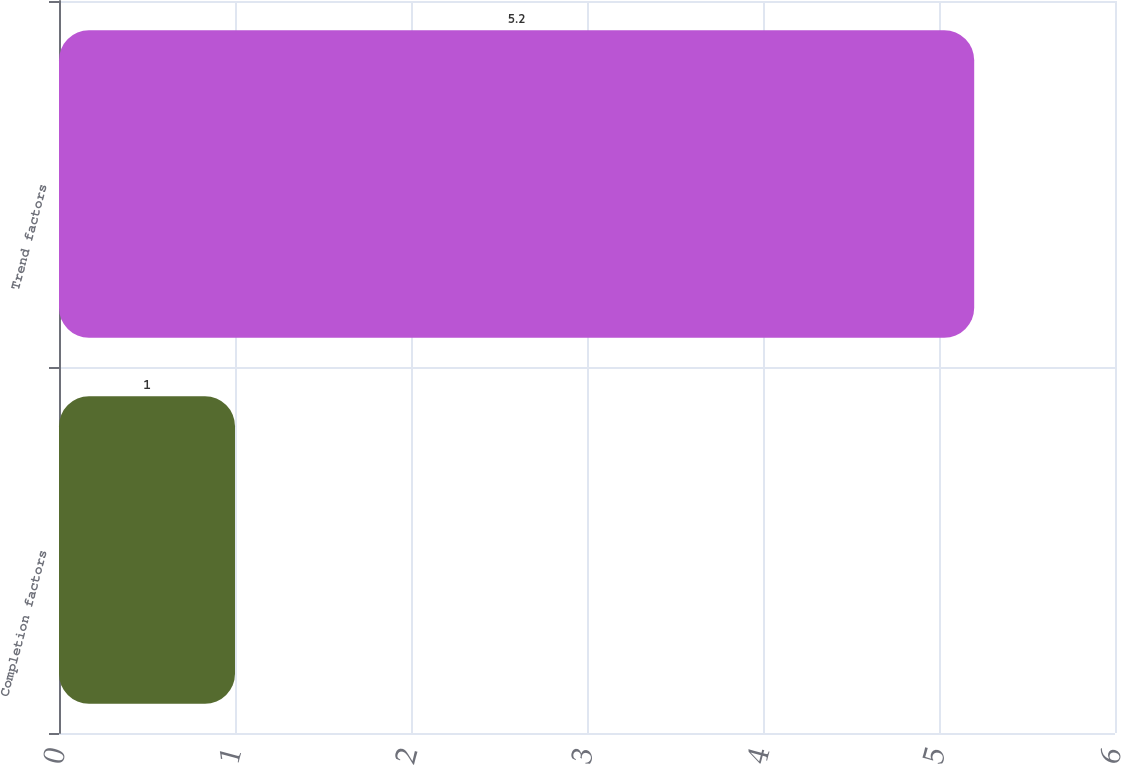Convert chart to OTSL. <chart><loc_0><loc_0><loc_500><loc_500><bar_chart><fcel>Completion factors<fcel>Trend factors<nl><fcel>1<fcel>5.2<nl></chart> 